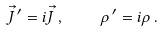<formula> <loc_0><loc_0><loc_500><loc_500>\vec { J } \, ^ { \prime } = i \vec { J } \, , \quad \rho \, ^ { \prime } = i \rho \, .</formula> 